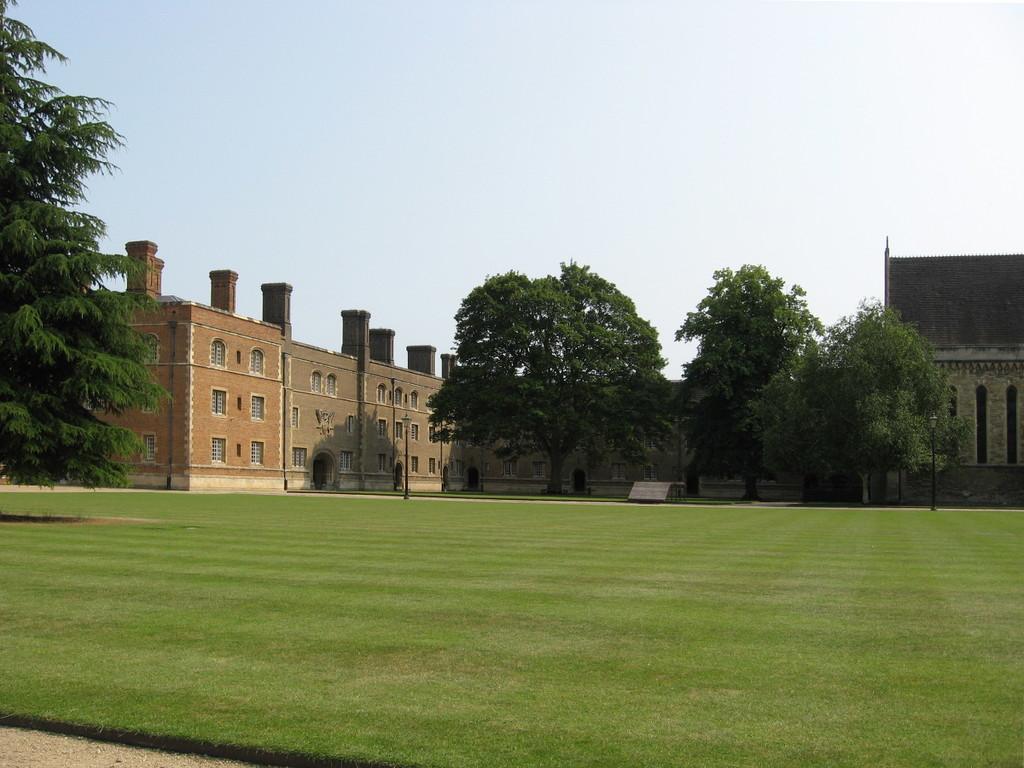In one or two sentences, can you explain what this image depicts? In the image we can see there is a ground which is covered with grass. Behind there are lot of trees and there are buildings. 